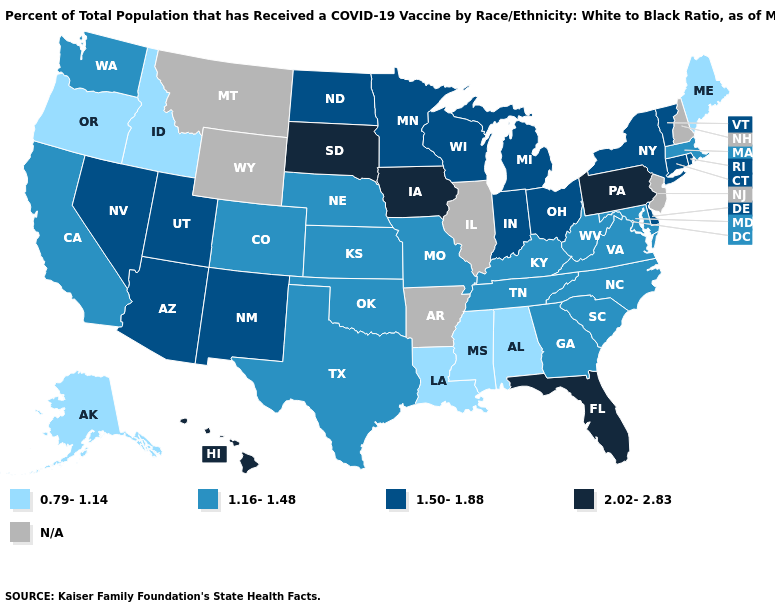What is the lowest value in the West?
Be succinct. 0.79-1.14. What is the highest value in the USA?
Quick response, please. 2.02-2.83. Name the states that have a value in the range 0.79-1.14?
Short answer required. Alabama, Alaska, Idaho, Louisiana, Maine, Mississippi, Oregon. What is the value of Kentucky?
Keep it brief. 1.16-1.48. What is the value of Iowa?
Answer briefly. 2.02-2.83. What is the highest value in the USA?
Answer briefly. 2.02-2.83. What is the highest value in the USA?
Answer briefly. 2.02-2.83. Name the states that have a value in the range 1.50-1.88?
Keep it brief. Arizona, Connecticut, Delaware, Indiana, Michigan, Minnesota, Nevada, New Mexico, New York, North Dakota, Ohio, Rhode Island, Utah, Vermont, Wisconsin. What is the value of Washington?
Give a very brief answer. 1.16-1.48. Among the states that border South Carolina , which have the lowest value?
Give a very brief answer. Georgia, North Carolina. Among the states that border Delaware , does Pennsylvania have the highest value?
Short answer required. Yes. Does Florida have the highest value in the South?
Write a very short answer. Yes. What is the lowest value in states that border Oklahoma?
Answer briefly. 1.16-1.48. Which states have the lowest value in the USA?
Quick response, please. Alabama, Alaska, Idaho, Louisiana, Maine, Mississippi, Oregon. Does Iowa have the highest value in the USA?
Short answer required. Yes. 